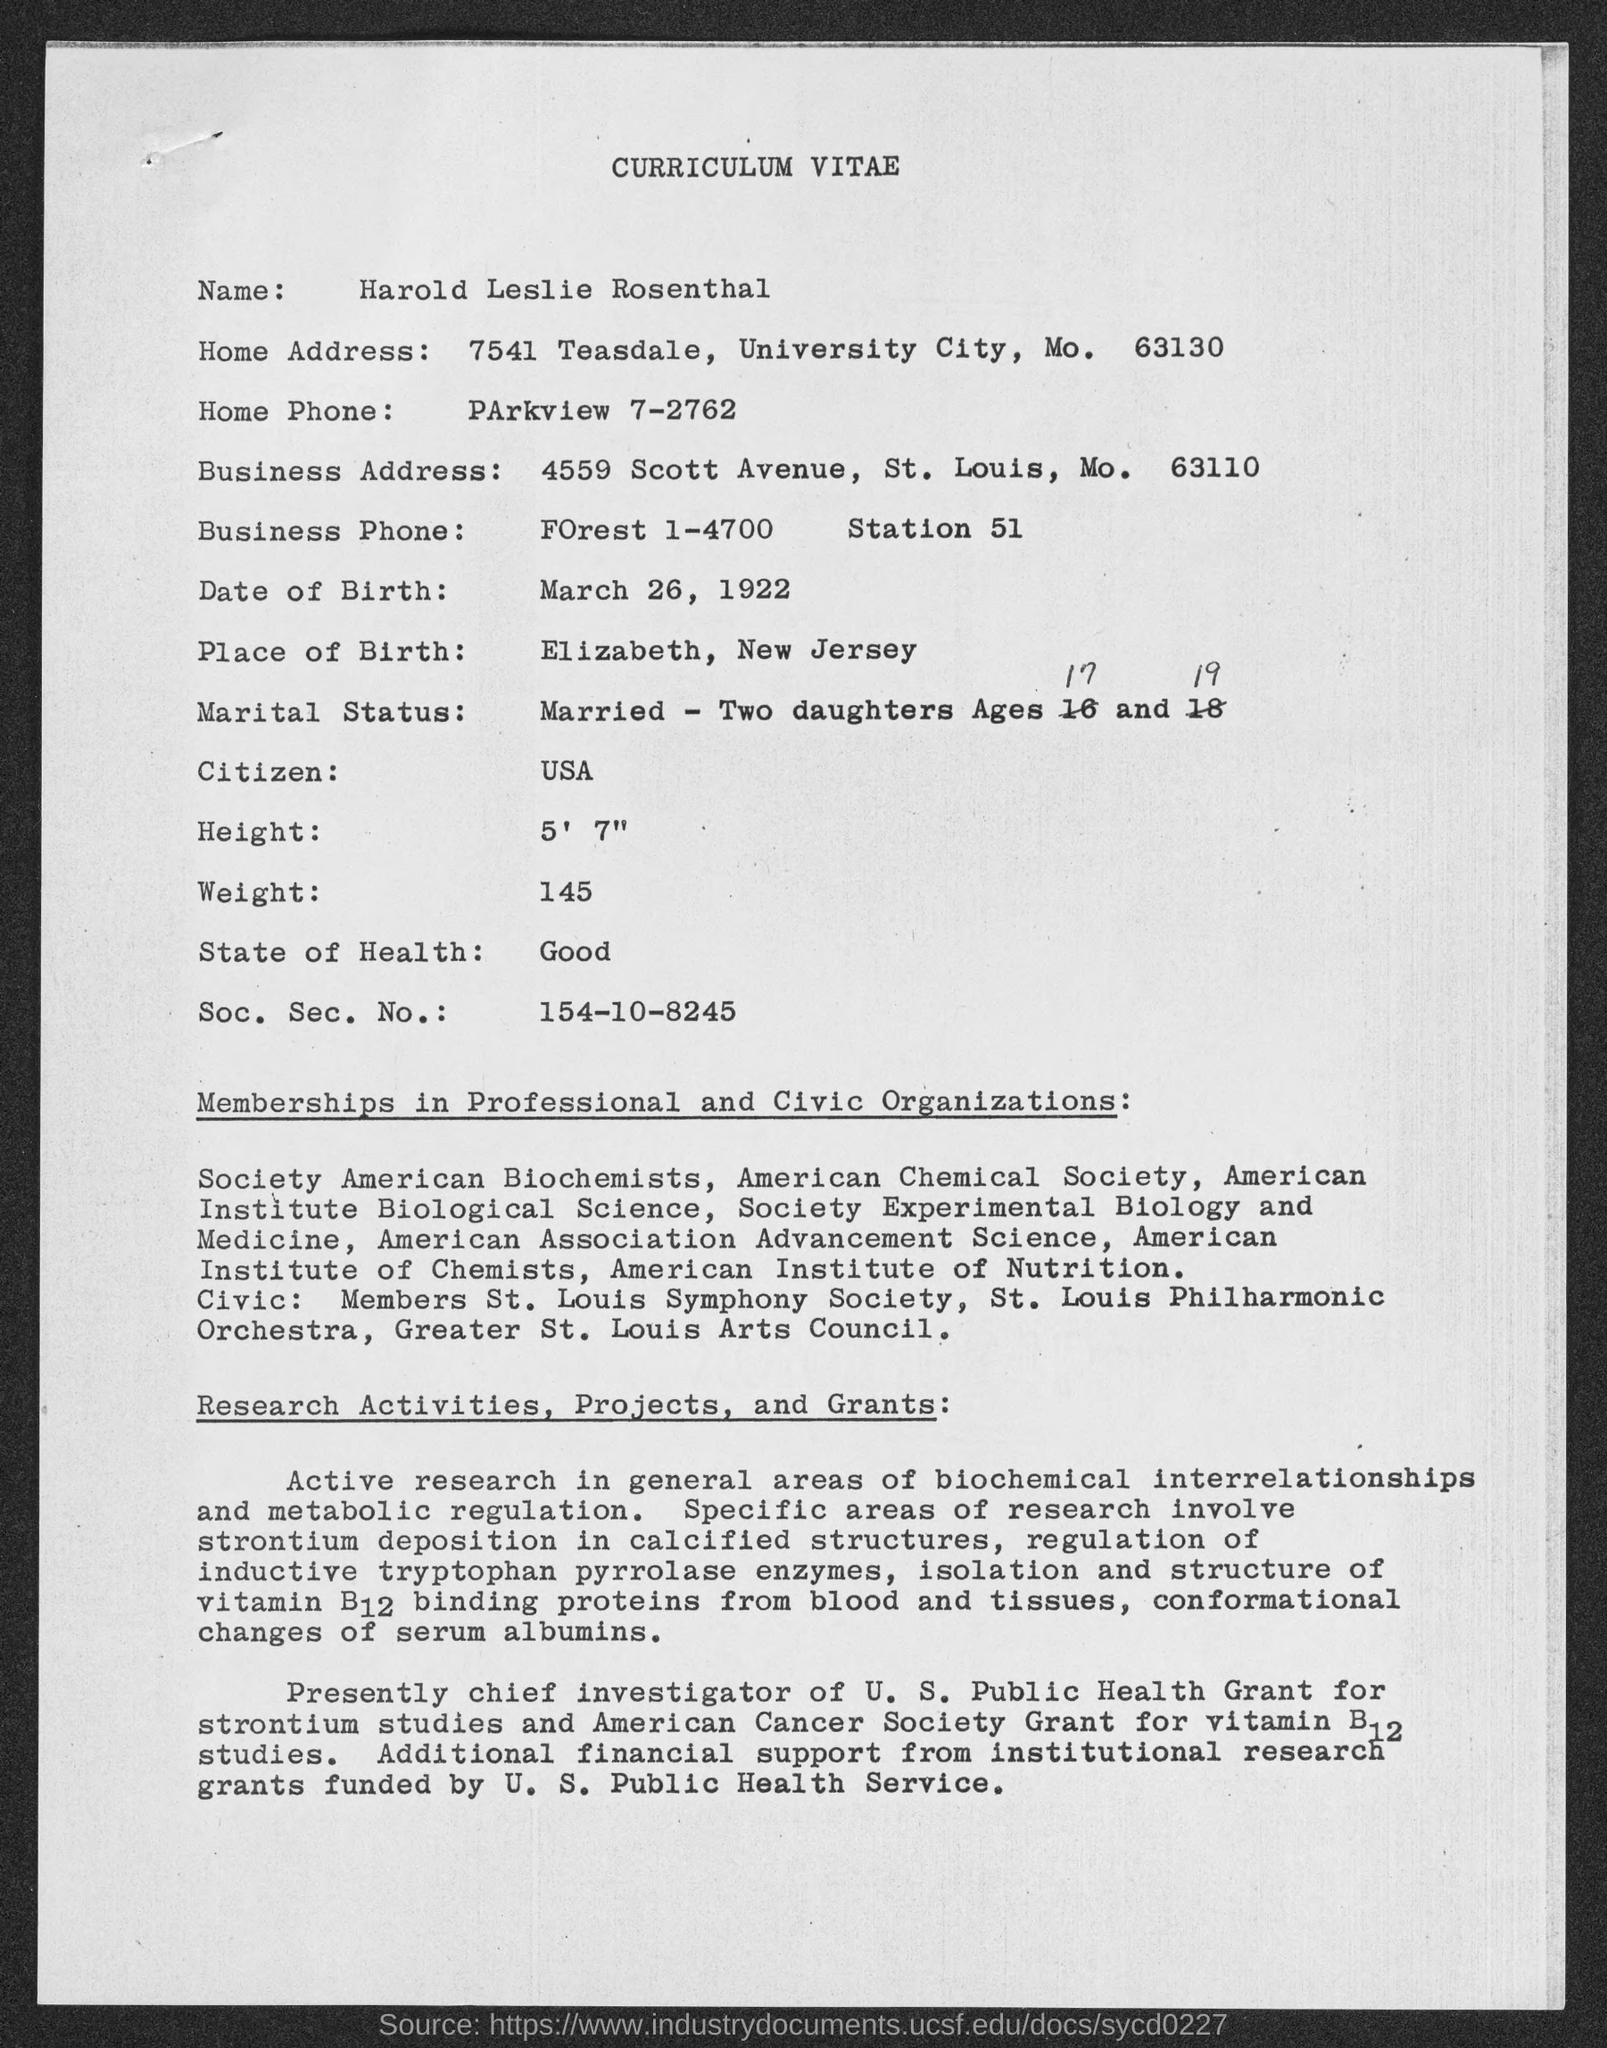What type of documentation is this?
Your answer should be very brief. CURRICULUM VITAE. What is the name given?
Provide a succinct answer. Harold Leslie Rosenthal. What is the Home Phone given?
Your answer should be very brief. Parkview 7-2762. What is the date of birth given?
Your response must be concise. March 26, 1922. What is his height?
Your answer should be compact. 5' 7". What is the Soc. Sec. No.?
Your answer should be very brief. 154-10-8245. 